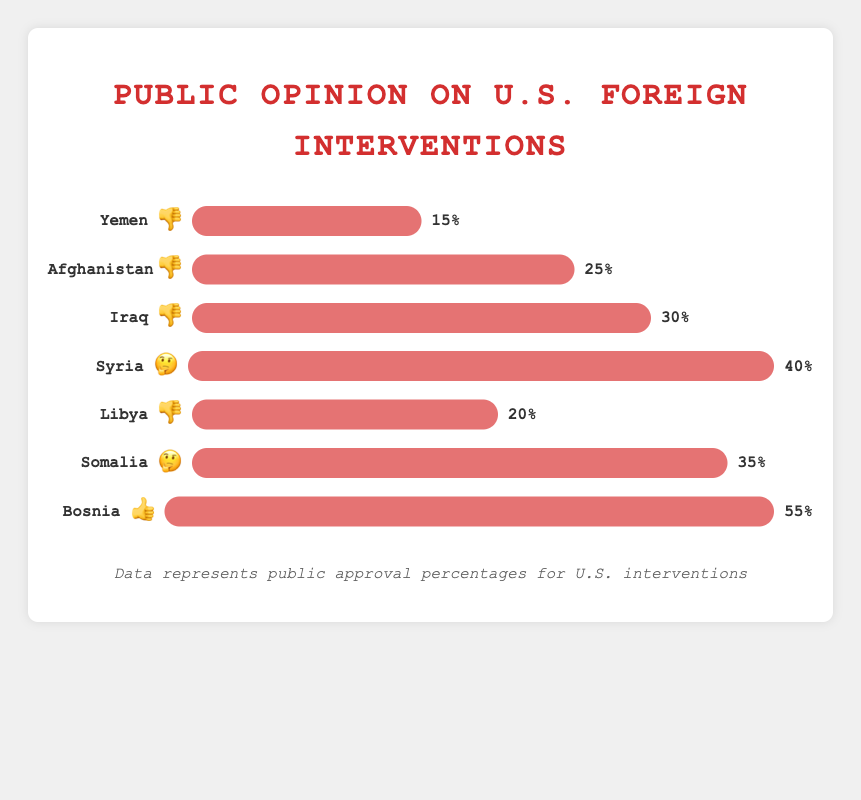Which country has the highest approval rating? The figure shows different approval ratings for each country, and the one with the highest value is Bosnia at 55%.
Answer: Bosnia What's the approval percentage and emoji for Yemen? The figure shows approval ratings and emojis for each country. For Yemen, it's 👎 and 15%.
Answer: 👎, 15% How many countries have a 🤔 approval rating? The figure lists countries with different emoji ratings, and specifically for 🤔, there are Syria and Somalia, making it 2 countries.
Answer: 2 What is the total approval percentage for countries with a 👎 rating? Adding the percentages for Yemen (15%), Afghanistan (25%), Iraq (30%), and Libya (20%), the total is 15 + 25 + 30 + 20 = 90%.
Answer: 90% Compare the approval percentages of Syria and Somalia. Which one is higher and by how much? The figure shows Syria has 40% and Somalia has 35%. The difference is 40 - 35 = 5%. So, Syria has a higher approval by 5%.
Answer: Syria by 5% What is the most common approval emoji used in the chart? By counting the emojis for each country: 👎 appears 4 times, 🤔 appears 2 times, and 👍 appears 1 time. The most frequent one is 👎.
Answer: 👎 Which country has the lowest approval percentage, and what is it? The figure shows various approval percentages, with the lowest being Yemen at 15%.
Answer: Yemen 15% What is the average approval percentage for all the countries listed? Adding the percentages for all countries: 15 + 25 + 30 + 40 + 20 + 35 + 55 = 220. There are 7 countries, so the average is 220/7 ≈ 31.4%.
Answer: 31.4% Does any country have exactly 50% approval? Looking through the figure, no country has an approval rating of exactly 50%.
Answer: No Which countries have an approval rating less than 30%? Checking the approval percentages, Yemen (15%), Afghanistan (25%), and Libya (20%) have less than 30%.
Answer: Yemen, Afghanistan, Libya 